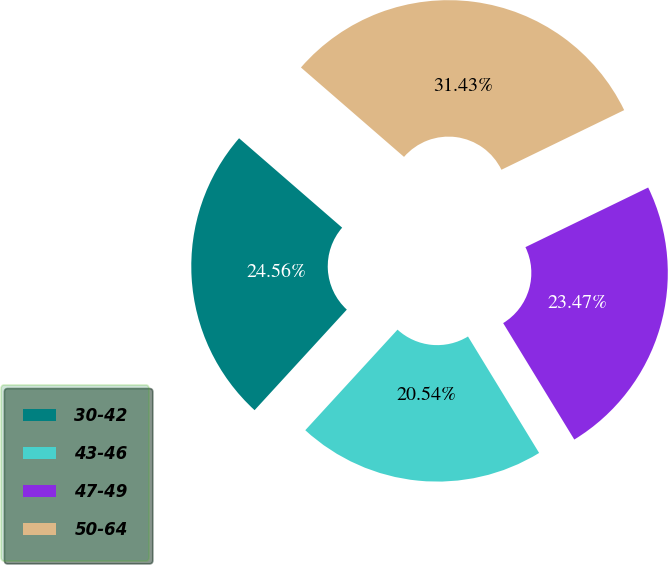<chart> <loc_0><loc_0><loc_500><loc_500><pie_chart><fcel>30-42<fcel>43-46<fcel>47-49<fcel>50-64<nl><fcel>24.56%<fcel>20.54%<fcel>23.47%<fcel>31.43%<nl></chart> 